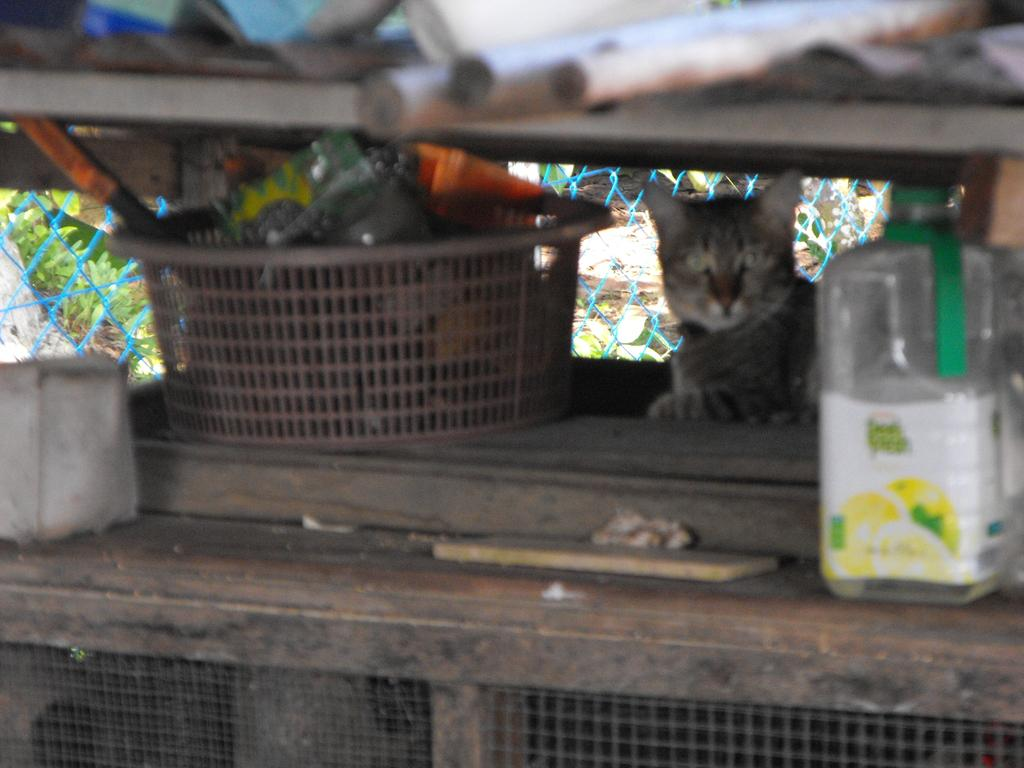What type of animal can be seen in the image? There is a cat in the image. What object made of plastic is present in the image? There is a plastic bottle and a plastic basket in the image. What is the purpose of the plastic basket in the image? The plastic basket contains some things, suggesting it is being used for storage or organization. Can you find the receipt for the cat's purchase in the image? There is no receipt present in the image, as it is focused on the cat, plastic bottle, and plastic basket. Is there a railway visible in the image? There is no railway present in the image; it features a cat, plastic bottle, and plastic basket. 